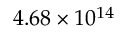<formula> <loc_0><loc_0><loc_500><loc_500>4 . 6 8 \times 1 0 ^ { 1 4 }</formula> 